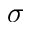Convert formula to latex. <formula><loc_0><loc_0><loc_500><loc_500>\sigma</formula> 